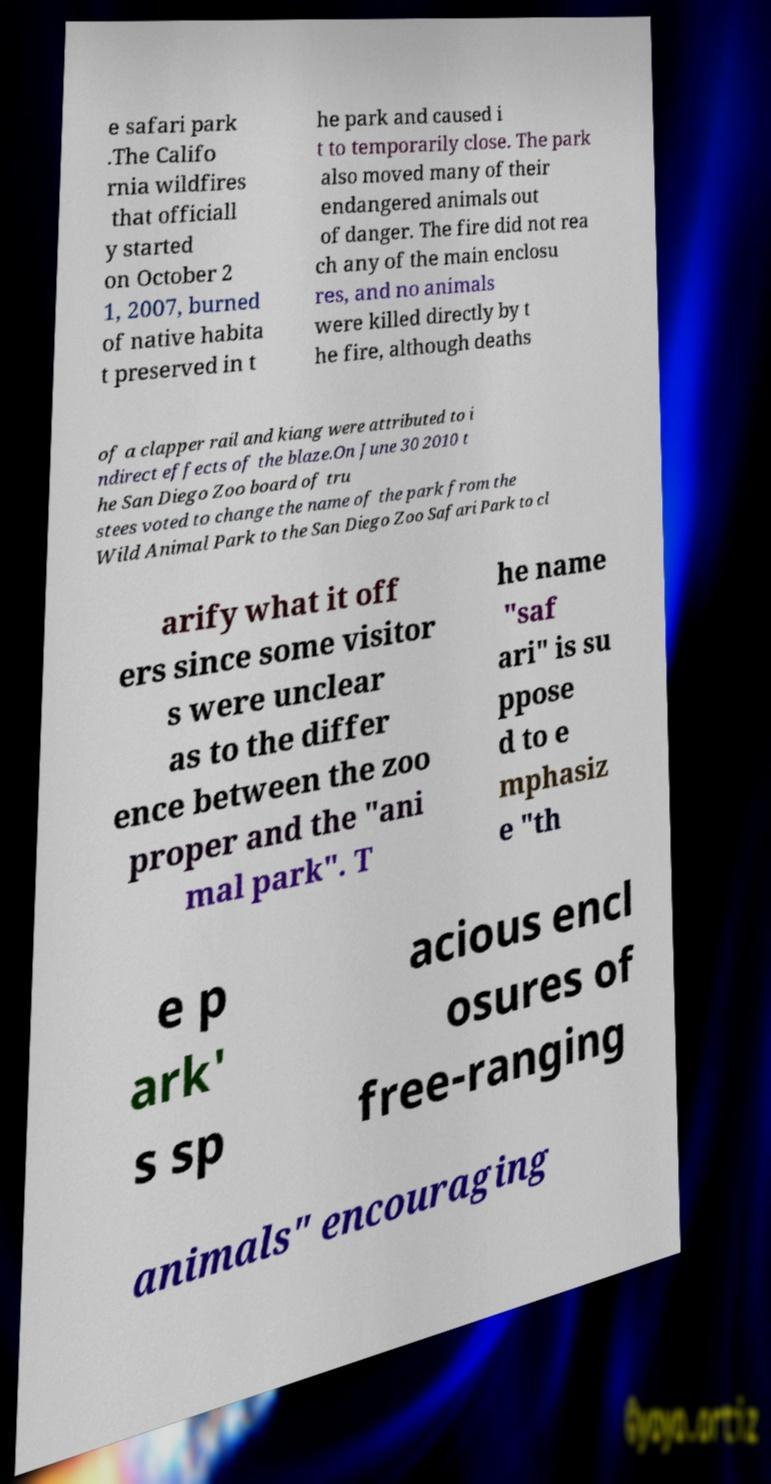Please identify and transcribe the text found in this image. e safari park .The Califo rnia wildfires that officiall y started on October 2 1, 2007, burned of native habita t preserved in t he park and caused i t to temporarily close. The park also moved many of their endangered animals out of danger. The fire did not rea ch any of the main enclosu res, and no animals were killed directly by t he fire, although deaths of a clapper rail and kiang were attributed to i ndirect effects of the blaze.On June 30 2010 t he San Diego Zoo board of tru stees voted to change the name of the park from the Wild Animal Park to the San Diego Zoo Safari Park to cl arify what it off ers since some visitor s were unclear as to the differ ence between the zoo proper and the "ani mal park". T he name "saf ari" is su ppose d to e mphasiz e "th e p ark' s sp acious encl osures of free-ranging animals" encouraging 